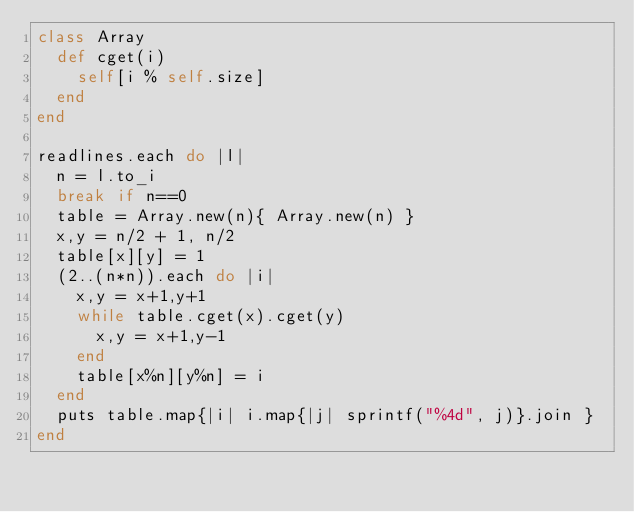<code> <loc_0><loc_0><loc_500><loc_500><_Ruby_>class Array
  def cget(i)
    self[i % self.size]
  end
end

readlines.each do |l|
  n = l.to_i
  break if n==0
  table = Array.new(n){ Array.new(n) }
  x,y = n/2 + 1, n/2
  table[x][y] = 1
  (2..(n*n)).each do |i|
    x,y = x+1,y+1
    while table.cget(x).cget(y)
      x,y = x+1,y-1
    end
    table[x%n][y%n] = i
  end
  puts table.map{|i| i.map{|j| sprintf("%4d", j)}.join }
end</code> 